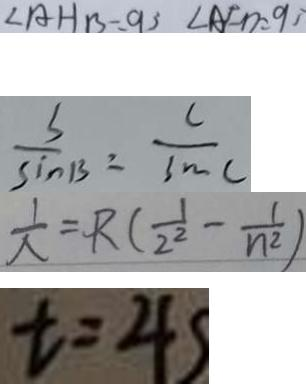Convert formula to latex. <formula><loc_0><loc_0><loc_500><loc_500>\angle A H B - \angle 9 3 \angle A F D = 9 3 
 \frac { s } { \sin B } = \frac { c } { \sin C } 
 \frac { 1 } { \lambda } = R ( \frac { 1 } { 2 ^ { 2 } } - \frac { 1 } { n ^ { 2 } } ) 
 t = 4 s</formula> 